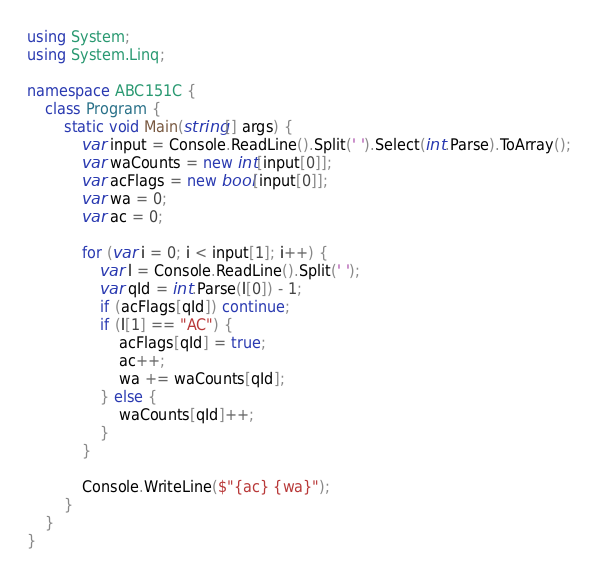Convert code to text. <code><loc_0><loc_0><loc_500><loc_500><_C#_>using System;
using System.Linq;

namespace ABC151C {
    class Program {
        static void Main(string[] args) {
            var input = Console.ReadLine().Split(' ').Select(int.Parse).ToArray();
            var waCounts = new int[input[0]];
            var acFlags = new bool[input[0]];
            var wa = 0;
            var ac = 0;
            
            for (var i = 0; i < input[1]; i++) {
                var l = Console.ReadLine().Split(' ');
                var qId = int.Parse(l[0]) - 1;
                if (acFlags[qId]) continue;
                if (l[1] == "AC") {
                    acFlags[qId] = true;
                    ac++;
                    wa += waCounts[qId];
                } else {
                    waCounts[qId]++;
                }
            }

            Console.WriteLine($"{ac} {wa}");
        }
    }
}</code> 